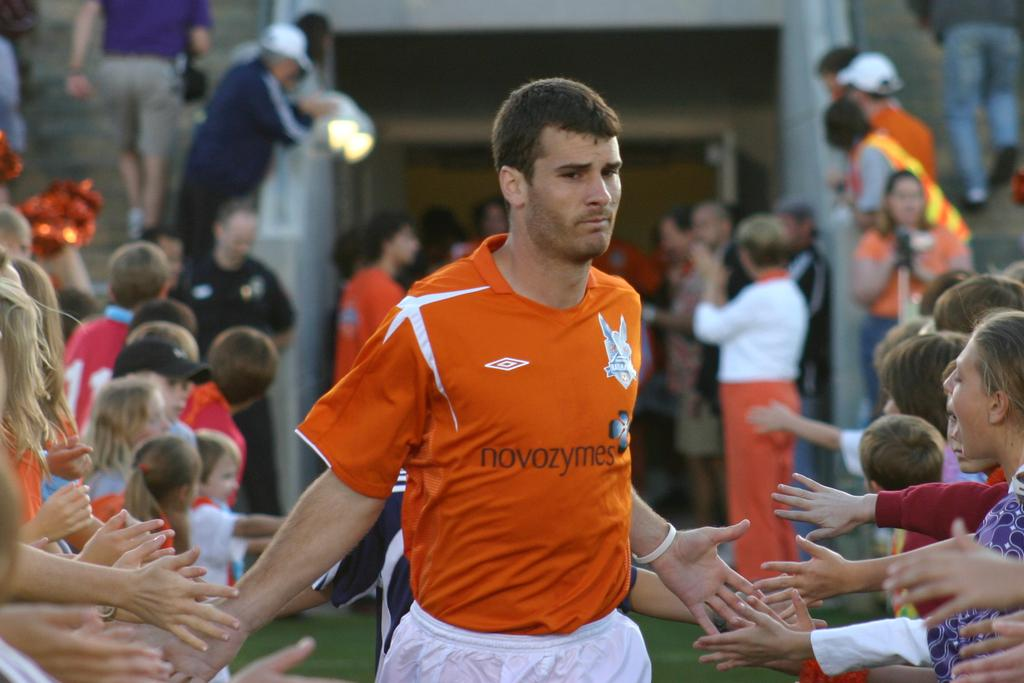<image>
Summarize the visual content of the image. Professional soccer player wearing an orange noveozymese shirt palms fans with both his hands before going onto the playing field 